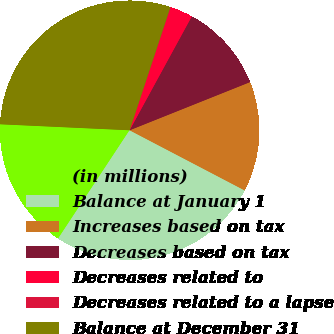Convert chart to OTSL. <chart><loc_0><loc_0><loc_500><loc_500><pie_chart><fcel>(in millions)<fcel>Balance at January 1<fcel>Increases based on tax<fcel>Decreases based on tax<fcel>Decreases related to<fcel>Decreases related to a lapse<fcel>Balance at December 31<nl><fcel>16.45%<fcel>26.61%<fcel>13.72%<fcel>10.99%<fcel>2.8%<fcel>0.07%<fcel>29.34%<nl></chart> 